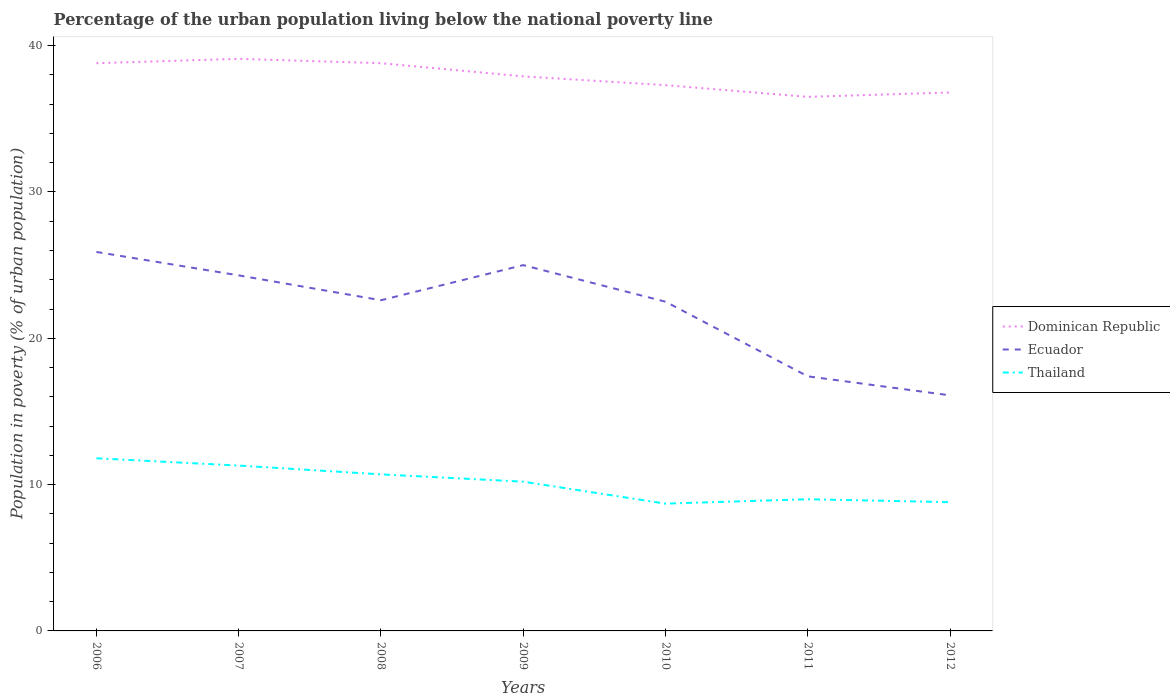How many different coloured lines are there?
Your response must be concise. 3. Across all years, what is the maximum percentage of the urban population living below the national poverty line in Ecuador?
Provide a succinct answer. 16.1. What is the total percentage of the urban population living below the national poverty line in Dominican Republic in the graph?
Offer a terse response. 2.3. What is the difference between the highest and the second highest percentage of the urban population living below the national poverty line in Thailand?
Your answer should be very brief. 3.1. Is the percentage of the urban population living below the national poverty line in Dominican Republic strictly greater than the percentage of the urban population living below the national poverty line in Thailand over the years?
Ensure brevity in your answer.  No. How many years are there in the graph?
Offer a terse response. 7. What is the difference between two consecutive major ticks on the Y-axis?
Make the answer very short. 10. Are the values on the major ticks of Y-axis written in scientific E-notation?
Your answer should be very brief. No. Where does the legend appear in the graph?
Keep it short and to the point. Center right. What is the title of the graph?
Your response must be concise. Percentage of the urban population living below the national poverty line. What is the label or title of the Y-axis?
Ensure brevity in your answer.  Population in poverty (% of urban population). What is the Population in poverty (% of urban population) of Dominican Republic in 2006?
Ensure brevity in your answer.  38.8. What is the Population in poverty (% of urban population) in Ecuador in 2006?
Provide a short and direct response. 25.9. What is the Population in poverty (% of urban population) in Thailand in 2006?
Offer a terse response. 11.8. What is the Population in poverty (% of urban population) in Dominican Republic in 2007?
Make the answer very short. 39.1. What is the Population in poverty (% of urban population) of Ecuador in 2007?
Make the answer very short. 24.3. What is the Population in poverty (% of urban population) of Thailand in 2007?
Your response must be concise. 11.3. What is the Population in poverty (% of urban population) of Dominican Republic in 2008?
Keep it short and to the point. 38.8. What is the Population in poverty (% of urban population) in Ecuador in 2008?
Provide a short and direct response. 22.6. What is the Population in poverty (% of urban population) of Dominican Republic in 2009?
Your answer should be compact. 37.9. What is the Population in poverty (% of urban population) in Dominican Republic in 2010?
Your answer should be very brief. 37.3. What is the Population in poverty (% of urban population) in Ecuador in 2010?
Offer a terse response. 22.5. What is the Population in poverty (% of urban population) in Thailand in 2010?
Provide a short and direct response. 8.7. What is the Population in poverty (% of urban population) in Dominican Republic in 2011?
Give a very brief answer. 36.5. What is the Population in poverty (% of urban population) in Thailand in 2011?
Your answer should be very brief. 9. What is the Population in poverty (% of urban population) in Dominican Republic in 2012?
Make the answer very short. 36.8. What is the Population in poverty (% of urban population) of Ecuador in 2012?
Your response must be concise. 16.1. What is the Population in poverty (% of urban population) in Thailand in 2012?
Provide a succinct answer. 8.8. Across all years, what is the maximum Population in poverty (% of urban population) in Dominican Republic?
Offer a very short reply. 39.1. Across all years, what is the maximum Population in poverty (% of urban population) of Ecuador?
Offer a terse response. 25.9. Across all years, what is the minimum Population in poverty (% of urban population) in Dominican Republic?
Give a very brief answer. 36.5. Across all years, what is the minimum Population in poverty (% of urban population) in Ecuador?
Keep it short and to the point. 16.1. What is the total Population in poverty (% of urban population) of Dominican Republic in the graph?
Offer a terse response. 265.2. What is the total Population in poverty (% of urban population) of Ecuador in the graph?
Your answer should be compact. 153.8. What is the total Population in poverty (% of urban population) of Thailand in the graph?
Your answer should be very brief. 70.5. What is the difference between the Population in poverty (% of urban population) in Dominican Republic in 2006 and that in 2008?
Offer a terse response. 0. What is the difference between the Population in poverty (% of urban population) of Thailand in 2006 and that in 2009?
Your response must be concise. 1.6. What is the difference between the Population in poverty (% of urban population) in Ecuador in 2006 and that in 2010?
Your response must be concise. 3.4. What is the difference between the Population in poverty (% of urban population) of Thailand in 2006 and that in 2010?
Make the answer very short. 3.1. What is the difference between the Population in poverty (% of urban population) in Dominican Republic in 2006 and that in 2011?
Give a very brief answer. 2.3. What is the difference between the Population in poverty (% of urban population) in Ecuador in 2006 and that in 2011?
Offer a very short reply. 8.5. What is the difference between the Population in poverty (% of urban population) of Dominican Republic in 2006 and that in 2012?
Offer a terse response. 2. What is the difference between the Population in poverty (% of urban population) of Thailand in 2007 and that in 2008?
Your response must be concise. 0.6. What is the difference between the Population in poverty (% of urban population) in Thailand in 2007 and that in 2009?
Make the answer very short. 1.1. What is the difference between the Population in poverty (% of urban population) of Dominican Republic in 2007 and that in 2010?
Offer a very short reply. 1.8. What is the difference between the Population in poverty (% of urban population) in Ecuador in 2007 and that in 2010?
Your response must be concise. 1.8. What is the difference between the Population in poverty (% of urban population) of Thailand in 2007 and that in 2010?
Keep it short and to the point. 2.6. What is the difference between the Population in poverty (% of urban population) of Ecuador in 2007 and that in 2011?
Offer a terse response. 6.9. What is the difference between the Population in poverty (% of urban population) of Thailand in 2007 and that in 2011?
Your answer should be very brief. 2.3. What is the difference between the Population in poverty (% of urban population) in Dominican Republic in 2007 and that in 2012?
Provide a succinct answer. 2.3. What is the difference between the Population in poverty (% of urban population) of Dominican Republic in 2008 and that in 2009?
Your answer should be compact. 0.9. What is the difference between the Population in poverty (% of urban population) of Thailand in 2008 and that in 2009?
Ensure brevity in your answer.  0.5. What is the difference between the Population in poverty (% of urban population) in Ecuador in 2008 and that in 2010?
Your answer should be very brief. 0.1. What is the difference between the Population in poverty (% of urban population) in Ecuador in 2008 and that in 2011?
Offer a very short reply. 5.2. What is the difference between the Population in poverty (% of urban population) of Thailand in 2008 and that in 2011?
Give a very brief answer. 1.7. What is the difference between the Population in poverty (% of urban population) of Dominican Republic in 2008 and that in 2012?
Provide a succinct answer. 2. What is the difference between the Population in poverty (% of urban population) of Ecuador in 2008 and that in 2012?
Your response must be concise. 6.5. What is the difference between the Population in poverty (% of urban population) of Thailand in 2009 and that in 2010?
Your answer should be very brief. 1.5. What is the difference between the Population in poverty (% of urban population) of Dominican Republic in 2009 and that in 2011?
Your answer should be compact. 1.4. What is the difference between the Population in poverty (% of urban population) in Ecuador in 2009 and that in 2011?
Keep it short and to the point. 7.6. What is the difference between the Population in poverty (% of urban population) of Dominican Republic in 2009 and that in 2012?
Give a very brief answer. 1.1. What is the difference between the Population in poverty (% of urban population) in Ecuador in 2009 and that in 2012?
Ensure brevity in your answer.  8.9. What is the difference between the Population in poverty (% of urban population) in Thailand in 2009 and that in 2012?
Keep it short and to the point. 1.4. What is the difference between the Population in poverty (% of urban population) in Ecuador in 2010 and that in 2011?
Give a very brief answer. 5.1. What is the difference between the Population in poverty (% of urban population) of Thailand in 2011 and that in 2012?
Offer a very short reply. 0.2. What is the difference between the Population in poverty (% of urban population) of Dominican Republic in 2006 and the Population in poverty (% of urban population) of Thailand in 2008?
Your response must be concise. 28.1. What is the difference between the Population in poverty (% of urban population) of Ecuador in 2006 and the Population in poverty (% of urban population) of Thailand in 2008?
Your answer should be very brief. 15.2. What is the difference between the Population in poverty (% of urban population) in Dominican Republic in 2006 and the Population in poverty (% of urban population) in Thailand in 2009?
Make the answer very short. 28.6. What is the difference between the Population in poverty (% of urban population) of Ecuador in 2006 and the Population in poverty (% of urban population) of Thailand in 2009?
Your response must be concise. 15.7. What is the difference between the Population in poverty (% of urban population) in Dominican Republic in 2006 and the Population in poverty (% of urban population) in Thailand in 2010?
Make the answer very short. 30.1. What is the difference between the Population in poverty (% of urban population) of Dominican Republic in 2006 and the Population in poverty (% of urban population) of Ecuador in 2011?
Provide a short and direct response. 21.4. What is the difference between the Population in poverty (% of urban population) in Dominican Republic in 2006 and the Population in poverty (% of urban population) in Thailand in 2011?
Ensure brevity in your answer.  29.8. What is the difference between the Population in poverty (% of urban population) in Dominican Republic in 2006 and the Population in poverty (% of urban population) in Ecuador in 2012?
Your response must be concise. 22.7. What is the difference between the Population in poverty (% of urban population) in Dominican Republic in 2006 and the Population in poverty (% of urban population) in Thailand in 2012?
Offer a very short reply. 30. What is the difference between the Population in poverty (% of urban population) of Dominican Republic in 2007 and the Population in poverty (% of urban population) of Ecuador in 2008?
Keep it short and to the point. 16.5. What is the difference between the Population in poverty (% of urban population) of Dominican Republic in 2007 and the Population in poverty (% of urban population) of Thailand in 2008?
Provide a succinct answer. 28.4. What is the difference between the Population in poverty (% of urban population) in Dominican Republic in 2007 and the Population in poverty (% of urban population) in Thailand in 2009?
Offer a terse response. 28.9. What is the difference between the Population in poverty (% of urban population) in Dominican Republic in 2007 and the Population in poverty (% of urban population) in Ecuador in 2010?
Give a very brief answer. 16.6. What is the difference between the Population in poverty (% of urban population) in Dominican Republic in 2007 and the Population in poverty (% of urban population) in Thailand in 2010?
Give a very brief answer. 30.4. What is the difference between the Population in poverty (% of urban population) in Dominican Republic in 2007 and the Population in poverty (% of urban population) in Ecuador in 2011?
Your answer should be compact. 21.7. What is the difference between the Population in poverty (% of urban population) of Dominican Republic in 2007 and the Population in poverty (% of urban population) of Thailand in 2011?
Provide a short and direct response. 30.1. What is the difference between the Population in poverty (% of urban population) of Dominican Republic in 2007 and the Population in poverty (% of urban population) of Ecuador in 2012?
Ensure brevity in your answer.  23. What is the difference between the Population in poverty (% of urban population) of Dominican Republic in 2007 and the Population in poverty (% of urban population) of Thailand in 2012?
Give a very brief answer. 30.3. What is the difference between the Population in poverty (% of urban population) of Dominican Republic in 2008 and the Population in poverty (% of urban population) of Thailand in 2009?
Ensure brevity in your answer.  28.6. What is the difference between the Population in poverty (% of urban population) of Dominican Republic in 2008 and the Population in poverty (% of urban population) of Thailand in 2010?
Provide a short and direct response. 30.1. What is the difference between the Population in poverty (% of urban population) in Dominican Republic in 2008 and the Population in poverty (% of urban population) in Ecuador in 2011?
Your answer should be compact. 21.4. What is the difference between the Population in poverty (% of urban population) of Dominican Republic in 2008 and the Population in poverty (% of urban population) of Thailand in 2011?
Keep it short and to the point. 29.8. What is the difference between the Population in poverty (% of urban population) in Ecuador in 2008 and the Population in poverty (% of urban population) in Thailand in 2011?
Ensure brevity in your answer.  13.6. What is the difference between the Population in poverty (% of urban population) in Dominican Republic in 2008 and the Population in poverty (% of urban population) in Ecuador in 2012?
Offer a terse response. 22.7. What is the difference between the Population in poverty (% of urban population) of Dominican Republic in 2008 and the Population in poverty (% of urban population) of Thailand in 2012?
Ensure brevity in your answer.  30. What is the difference between the Population in poverty (% of urban population) in Ecuador in 2008 and the Population in poverty (% of urban population) in Thailand in 2012?
Offer a terse response. 13.8. What is the difference between the Population in poverty (% of urban population) of Dominican Republic in 2009 and the Population in poverty (% of urban population) of Ecuador in 2010?
Your answer should be compact. 15.4. What is the difference between the Population in poverty (% of urban population) of Dominican Republic in 2009 and the Population in poverty (% of urban population) of Thailand in 2010?
Keep it short and to the point. 29.2. What is the difference between the Population in poverty (% of urban population) of Dominican Republic in 2009 and the Population in poverty (% of urban population) of Ecuador in 2011?
Provide a succinct answer. 20.5. What is the difference between the Population in poverty (% of urban population) of Dominican Republic in 2009 and the Population in poverty (% of urban population) of Thailand in 2011?
Offer a very short reply. 28.9. What is the difference between the Population in poverty (% of urban population) of Dominican Republic in 2009 and the Population in poverty (% of urban population) of Ecuador in 2012?
Ensure brevity in your answer.  21.8. What is the difference between the Population in poverty (% of urban population) in Dominican Republic in 2009 and the Population in poverty (% of urban population) in Thailand in 2012?
Provide a succinct answer. 29.1. What is the difference between the Population in poverty (% of urban population) in Dominican Republic in 2010 and the Population in poverty (% of urban population) in Ecuador in 2011?
Offer a terse response. 19.9. What is the difference between the Population in poverty (% of urban population) in Dominican Republic in 2010 and the Population in poverty (% of urban population) in Thailand in 2011?
Make the answer very short. 28.3. What is the difference between the Population in poverty (% of urban population) of Dominican Republic in 2010 and the Population in poverty (% of urban population) of Ecuador in 2012?
Give a very brief answer. 21.2. What is the difference between the Population in poverty (% of urban population) in Dominican Republic in 2010 and the Population in poverty (% of urban population) in Thailand in 2012?
Your answer should be very brief. 28.5. What is the difference between the Population in poverty (% of urban population) of Ecuador in 2010 and the Population in poverty (% of urban population) of Thailand in 2012?
Provide a short and direct response. 13.7. What is the difference between the Population in poverty (% of urban population) of Dominican Republic in 2011 and the Population in poverty (% of urban population) of Ecuador in 2012?
Ensure brevity in your answer.  20.4. What is the difference between the Population in poverty (% of urban population) in Dominican Republic in 2011 and the Population in poverty (% of urban population) in Thailand in 2012?
Your answer should be compact. 27.7. What is the difference between the Population in poverty (% of urban population) of Ecuador in 2011 and the Population in poverty (% of urban population) of Thailand in 2012?
Offer a terse response. 8.6. What is the average Population in poverty (% of urban population) in Dominican Republic per year?
Provide a succinct answer. 37.89. What is the average Population in poverty (% of urban population) in Ecuador per year?
Make the answer very short. 21.97. What is the average Population in poverty (% of urban population) of Thailand per year?
Your answer should be very brief. 10.07. In the year 2006, what is the difference between the Population in poverty (% of urban population) of Dominican Republic and Population in poverty (% of urban population) of Thailand?
Provide a short and direct response. 27. In the year 2007, what is the difference between the Population in poverty (% of urban population) of Dominican Republic and Population in poverty (% of urban population) of Thailand?
Your answer should be very brief. 27.8. In the year 2008, what is the difference between the Population in poverty (% of urban population) of Dominican Republic and Population in poverty (% of urban population) of Thailand?
Your answer should be compact. 28.1. In the year 2008, what is the difference between the Population in poverty (% of urban population) in Ecuador and Population in poverty (% of urban population) in Thailand?
Offer a very short reply. 11.9. In the year 2009, what is the difference between the Population in poverty (% of urban population) in Dominican Republic and Population in poverty (% of urban population) in Ecuador?
Provide a succinct answer. 12.9. In the year 2009, what is the difference between the Population in poverty (% of urban population) in Dominican Republic and Population in poverty (% of urban population) in Thailand?
Provide a short and direct response. 27.7. In the year 2009, what is the difference between the Population in poverty (% of urban population) of Ecuador and Population in poverty (% of urban population) of Thailand?
Offer a very short reply. 14.8. In the year 2010, what is the difference between the Population in poverty (% of urban population) in Dominican Republic and Population in poverty (% of urban population) in Ecuador?
Provide a short and direct response. 14.8. In the year 2010, what is the difference between the Population in poverty (% of urban population) of Dominican Republic and Population in poverty (% of urban population) of Thailand?
Provide a succinct answer. 28.6. In the year 2010, what is the difference between the Population in poverty (% of urban population) of Ecuador and Population in poverty (% of urban population) of Thailand?
Your answer should be very brief. 13.8. In the year 2011, what is the difference between the Population in poverty (% of urban population) in Dominican Republic and Population in poverty (% of urban population) in Thailand?
Offer a very short reply. 27.5. In the year 2011, what is the difference between the Population in poverty (% of urban population) of Ecuador and Population in poverty (% of urban population) of Thailand?
Ensure brevity in your answer.  8.4. In the year 2012, what is the difference between the Population in poverty (% of urban population) in Dominican Republic and Population in poverty (% of urban population) in Ecuador?
Offer a terse response. 20.7. In the year 2012, what is the difference between the Population in poverty (% of urban population) in Ecuador and Population in poverty (% of urban population) in Thailand?
Give a very brief answer. 7.3. What is the ratio of the Population in poverty (% of urban population) of Dominican Republic in 2006 to that in 2007?
Ensure brevity in your answer.  0.99. What is the ratio of the Population in poverty (% of urban population) in Ecuador in 2006 to that in 2007?
Make the answer very short. 1.07. What is the ratio of the Population in poverty (% of urban population) of Thailand in 2006 to that in 2007?
Ensure brevity in your answer.  1.04. What is the ratio of the Population in poverty (% of urban population) of Dominican Republic in 2006 to that in 2008?
Your answer should be compact. 1. What is the ratio of the Population in poverty (% of urban population) in Ecuador in 2006 to that in 2008?
Provide a succinct answer. 1.15. What is the ratio of the Population in poverty (% of urban population) in Thailand in 2006 to that in 2008?
Offer a very short reply. 1.1. What is the ratio of the Population in poverty (% of urban population) in Dominican Republic in 2006 to that in 2009?
Your answer should be very brief. 1.02. What is the ratio of the Population in poverty (% of urban population) of Ecuador in 2006 to that in 2009?
Keep it short and to the point. 1.04. What is the ratio of the Population in poverty (% of urban population) in Thailand in 2006 to that in 2009?
Provide a succinct answer. 1.16. What is the ratio of the Population in poverty (% of urban population) in Dominican Republic in 2006 to that in 2010?
Your response must be concise. 1.04. What is the ratio of the Population in poverty (% of urban population) of Ecuador in 2006 to that in 2010?
Give a very brief answer. 1.15. What is the ratio of the Population in poverty (% of urban population) of Thailand in 2006 to that in 2010?
Ensure brevity in your answer.  1.36. What is the ratio of the Population in poverty (% of urban population) in Dominican Republic in 2006 to that in 2011?
Your answer should be compact. 1.06. What is the ratio of the Population in poverty (% of urban population) of Ecuador in 2006 to that in 2011?
Make the answer very short. 1.49. What is the ratio of the Population in poverty (% of urban population) of Thailand in 2006 to that in 2011?
Offer a terse response. 1.31. What is the ratio of the Population in poverty (% of urban population) in Dominican Republic in 2006 to that in 2012?
Offer a terse response. 1.05. What is the ratio of the Population in poverty (% of urban population) in Ecuador in 2006 to that in 2012?
Your answer should be very brief. 1.61. What is the ratio of the Population in poverty (% of urban population) of Thailand in 2006 to that in 2012?
Provide a short and direct response. 1.34. What is the ratio of the Population in poverty (% of urban population) of Dominican Republic in 2007 to that in 2008?
Give a very brief answer. 1.01. What is the ratio of the Population in poverty (% of urban population) in Ecuador in 2007 to that in 2008?
Your response must be concise. 1.08. What is the ratio of the Population in poverty (% of urban population) in Thailand in 2007 to that in 2008?
Your response must be concise. 1.06. What is the ratio of the Population in poverty (% of urban population) of Dominican Republic in 2007 to that in 2009?
Offer a very short reply. 1.03. What is the ratio of the Population in poverty (% of urban population) of Thailand in 2007 to that in 2009?
Your response must be concise. 1.11. What is the ratio of the Population in poverty (% of urban population) in Dominican Republic in 2007 to that in 2010?
Ensure brevity in your answer.  1.05. What is the ratio of the Population in poverty (% of urban population) in Ecuador in 2007 to that in 2010?
Offer a terse response. 1.08. What is the ratio of the Population in poverty (% of urban population) in Thailand in 2007 to that in 2010?
Provide a succinct answer. 1.3. What is the ratio of the Population in poverty (% of urban population) in Dominican Republic in 2007 to that in 2011?
Give a very brief answer. 1.07. What is the ratio of the Population in poverty (% of urban population) of Ecuador in 2007 to that in 2011?
Keep it short and to the point. 1.4. What is the ratio of the Population in poverty (% of urban population) in Thailand in 2007 to that in 2011?
Your answer should be very brief. 1.26. What is the ratio of the Population in poverty (% of urban population) in Ecuador in 2007 to that in 2012?
Give a very brief answer. 1.51. What is the ratio of the Population in poverty (% of urban population) of Thailand in 2007 to that in 2012?
Make the answer very short. 1.28. What is the ratio of the Population in poverty (% of urban population) of Dominican Republic in 2008 to that in 2009?
Offer a terse response. 1.02. What is the ratio of the Population in poverty (% of urban population) in Ecuador in 2008 to that in 2009?
Your answer should be compact. 0.9. What is the ratio of the Population in poverty (% of urban population) of Thailand in 2008 to that in 2009?
Offer a terse response. 1.05. What is the ratio of the Population in poverty (% of urban population) of Dominican Republic in 2008 to that in 2010?
Provide a succinct answer. 1.04. What is the ratio of the Population in poverty (% of urban population) in Ecuador in 2008 to that in 2010?
Keep it short and to the point. 1. What is the ratio of the Population in poverty (% of urban population) of Thailand in 2008 to that in 2010?
Your answer should be very brief. 1.23. What is the ratio of the Population in poverty (% of urban population) of Dominican Republic in 2008 to that in 2011?
Provide a short and direct response. 1.06. What is the ratio of the Population in poverty (% of urban population) of Ecuador in 2008 to that in 2011?
Make the answer very short. 1.3. What is the ratio of the Population in poverty (% of urban population) in Thailand in 2008 to that in 2011?
Give a very brief answer. 1.19. What is the ratio of the Population in poverty (% of urban population) of Dominican Republic in 2008 to that in 2012?
Keep it short and to the point. 1.05. What is the ratio of the Population in poverty (% of urban population) of Ecuador in 2008 to that in 2012?
Your response must be concise. 1.4. What is the ratio of the Population in poverty (% of urban population) of Thailand in 2008 to that in 2012?
Ensure brevity in your answer.  1.22. What is the ratio of the Population in poverty (% of urban population) in Dominican Republic in 2009 to that in 2010?
Provide a succinct answer. 1.02. What is the ratio of the Population in poverty (% of urban population) of Thailand in 2009 to that in 2010?
Offer a terse response. 1.17. What is the ratio of the Population in poverty (% of urban population) in Dominican Republic in 2009 to that in 2011?
Give a very brief answer. 1.04. What is the ratio of the Population in poverty (% of urban population) of Ecuador in 2009 to that in 2011?
Your response must be concise. 1.44. What is the ratio of the Population in poverty (% of urban population) of Thailand in 2009 to that in 2011?
Give a very brief answer. 1.13. What is the ratio of the Population in poverty (% of urban population) in Dominican Republic in 2009 to that in 2012?
Keep it short and to the point. 1.03. What is the ratio of the Population in poverty (% of urban population) in Ecuador in 2009 to that in 2012?
Offer a very short reply. 1.55. What is the ratio of the Population in poverty (% of urban population) of Thailand in 2009 to that in 2012?
Offer a very short reply. 1.16. What is the ratio of the Population in poverty (% of urban population) in Dominican Republic in 2010 to that in 2011?
Provide a short and direct response. 1.02. What is the ratio of the Population in poverty (% of urban population) in Ecuador in 2010 to that in 2011?
Keep it short and to the point. 1.29. What is the ratio of the Population in poverty (% of urban population) of Thailand in 2010 to that in 2011?
Your answer should be very brief. 0.97. What is the ratio of the Population in poverty (% of urban population) of Dominican Republic in 2010 to that in 2012?
Give a very brief answer. 1.01. What is the ratio of the Population in poverty (% of urban population) of Ecuador in 2010 to that in 2012?
Ensure brevity in your answer.  1.4. What is the ratio of the Population in poverty (% of urban population) of Ecuador in 2011 to that in 2012?
Your answer should be compact. 1.08. What is the ratio of the Population in poverty (% of urban population) of Thailand in 2011 to that in 2012?
Your answer should be compact. 1.02. What is the difference between the highest and the lowest Population in poverty (% of urban population) in Dominican Republic?
Make the answer very short. 2.6. What is the difference between the highest and the lowest Population in poverty (% of urban population) in Thailand?
Offer a very short reply. 3.1. 